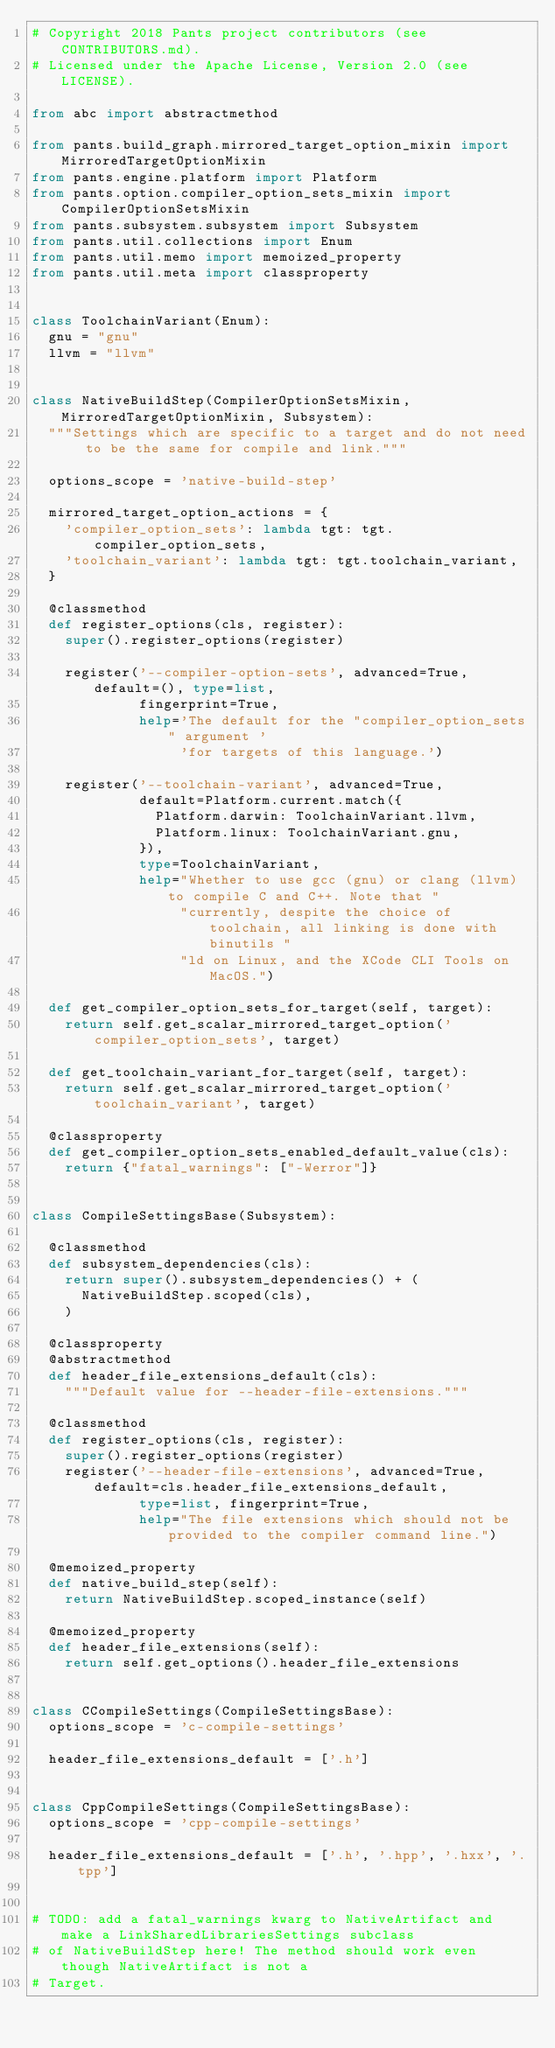<code> <loc_0><loc_0><loc_500><loc_500><_Python_># Copyright 2018 Pants project contributors (see CONTRIBUTORS.md).
# Licensed under the Apache License, Version 2.0 (see LICENSE).

from abc import abstractmethod

from pants.build_graph.mirrored_target_option_mixin import MirroredTargetOptionMixin
from pants.engine.platform import Platform
from pants.option.compiler_option_sets_mixin import CompilerOptionSetsMixin
from pants.subsystem.subsystem import Subsystem
from pants.util.collections import Enum
from pants.util.memo import memoized_property
from pants.util.meta import classproperty


class ToolchainVariant(Enum):
  gnu = "gnu"
  llvm = "llvm"


class NativeBuildStep(CompilerOptionSetsMixin, MirroredTargetOptionMixin, Subsystem):
  """Settings which are specific to a target and do not need to be the same for compile and link."""

  options_scope = 'native-build-step'

  mirrored_target_option_actions = {
    'compiler_option_sets': lambda tgt: tgt.compiler_option_sets,
    'toolchain_variant': lambda tgt: tgt.toolchain_variant,
  }

  @classmethod
  def register_options(cls, register):
    super().register_options(register)

    register('--compiler-option-sets', advanced=True, default=(), type=list,
             fingerprint=True,
             help='The default for the "compiler_option_sets" argument '
                  'for targets of this language.')

    register('--toolchain-variant', advanced=True,
             default=Platform.current.match({
               Platform.darwin: ToolchainVariant.llvm,
               Platform.linux: ToolchainVariant.gnu,
             }),
             type=ToolchainVariant,
             help="Whether to use gcc (gnu) or clang (llvm) to compile C and C++. Note that "
                  "currently, despite the choice of toolchain, all linking is done with binutils "
                  "ld on Linux, and the XCode CLI Tools on MacOS.")

  def get_compiler_option_sets_for_target(self, target):
    return self.get_scalar_mirrored_target_option('compiler_option_sets', target)

  def get_toolchain_variant_for_target(self, target):
    return self.get_scalar_mirrored_target_option('toolchain_variant', target)

  @classproperty
  def get_compiler_option_sets_enabled_default_value(cls):
    return {"fatal_warnings": ["-Werror"]}


class CompileSettingsBase(Subsystem):

  @classmethod
  def subsystem_dependencies(cls):
    return super().subsystem_dependencies() + (
      NativeBuildStep.scoped(cls),
    )

  @classproperty
  @abstractmethod
  def header_file_extensions_default(cls):
    """Default value for --header-file-extensions."""

  @classmethod
  def register_options(cls, register):
    super().register_options(register)
    register('--header-file-extensions', advanced=True, default=cls.header_file_extensions_default,
             type=list, fingerprint=True,
             help="The file extensions which should not be provided to the compiler command line.")

  @memoized_property
  def native_build_step(self):
    return NativeBuildStep.scoped_instance(self)

  @memoized_property
  def header_file_extensions(self):
    return self.get_options().header_file_extensions


class CCompileSettings(CompileSettingsBase):
  options_scope = 'c-compile-settings'

  header_file_extensions_default = ['.h']


class CppCompileSettings(CompileSettingsBase):
  options_scope = 'cpp-compile-settings'

  header_file_extensions_default = ['.h', '.hpp', '.hxx', '.tpp']


# TODO: add a fatal_warnings kwarg to NativeArtifact and make a LinkSharedLibrariesSettings subclass
# of NativeBuildStep here! The method should work even though NativeArtifact is not a
# Target.
</code> 